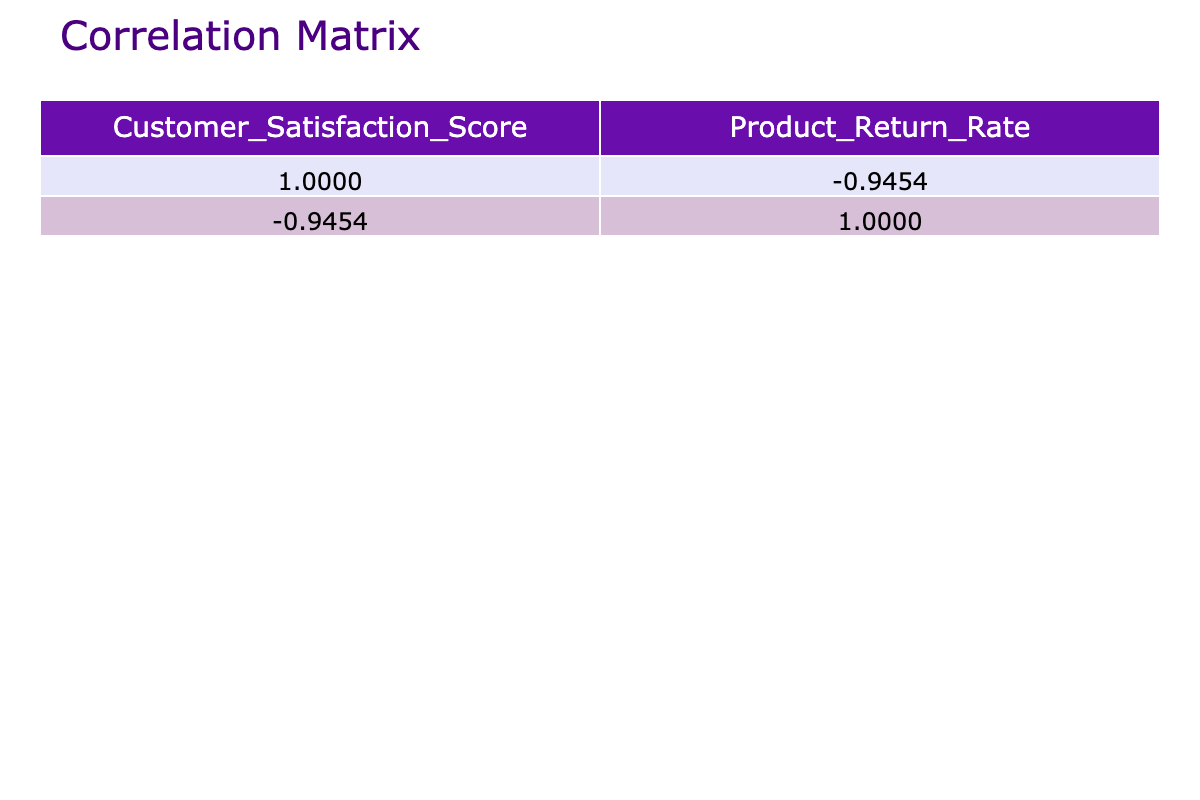What is the correlation coefficient between Customer Satisfaction Score and Product Return Rate? The correlation coefficients in the correlation table provide a quantitative measure of the relationship between the two variables. Looking at the table, the correlation coefficient between Customer Satisfaction Score and Product Return Rate is -0.8871, indicating a strong negative correlation.
Answer: -0.8871 What is the Customer Satisfaction Score for the highest Product Return Rate? To find this, we look for the maximum value in the Product Return Rate column, which is 3.7. Then, we find the corresponding Customer Satisfaction Score from the same row, which is 75.
Answer: 75 What is the average Product Return Rate for scores above 80? We first filter the Customer Satisfaction Scores that are above 80, which are 85, 90, 82, 88, and 92. The corresponding Product Return Rates are 2.5, 1.8, 2.0, 1.5, and 1.2. We calculate the sum of those Product Return Rates: 2.5 + 1.8 + 2.0 + 1.5 + 1.2 = 10.0. There are 5 values, so the average is 10.0 / 5 = 2.0.
Answer: 2.0 Is it true that a Customer Satisfaction Score of 90 has a lower Product Return Rate than a score of 80? We compare the Product Return Rates for the scores of 90 and 80. The Product Return Rate for a score of 90 is 1.8, while for a score of 80, it is 2.8. Since 1.8 is less than 2.8, the statement is true.
Answer: Yes What is the difference in average Product Return Rates between scores below and above 80? First, we identify the scores below 80, which are 78, 75, 76 (with Product Return Rates 3.2, 3.7, and 3.5), and above 80, which are 85, 90, 82, 88, and 92 (with Product Return Rates 2.5, 1.8, 2.0, 1.5, and 1.2). The average for scores below 80 is (3.2 + 3.7 + 3.5) / 3 = 3.47. The average for scores above 80 is (2.5 + 1.8 + 2.0 + 1.5 + 1.2) / 5 = 1.82. The difference is 3.47 - 1.82 = 1.65.
Answer: 1.65 